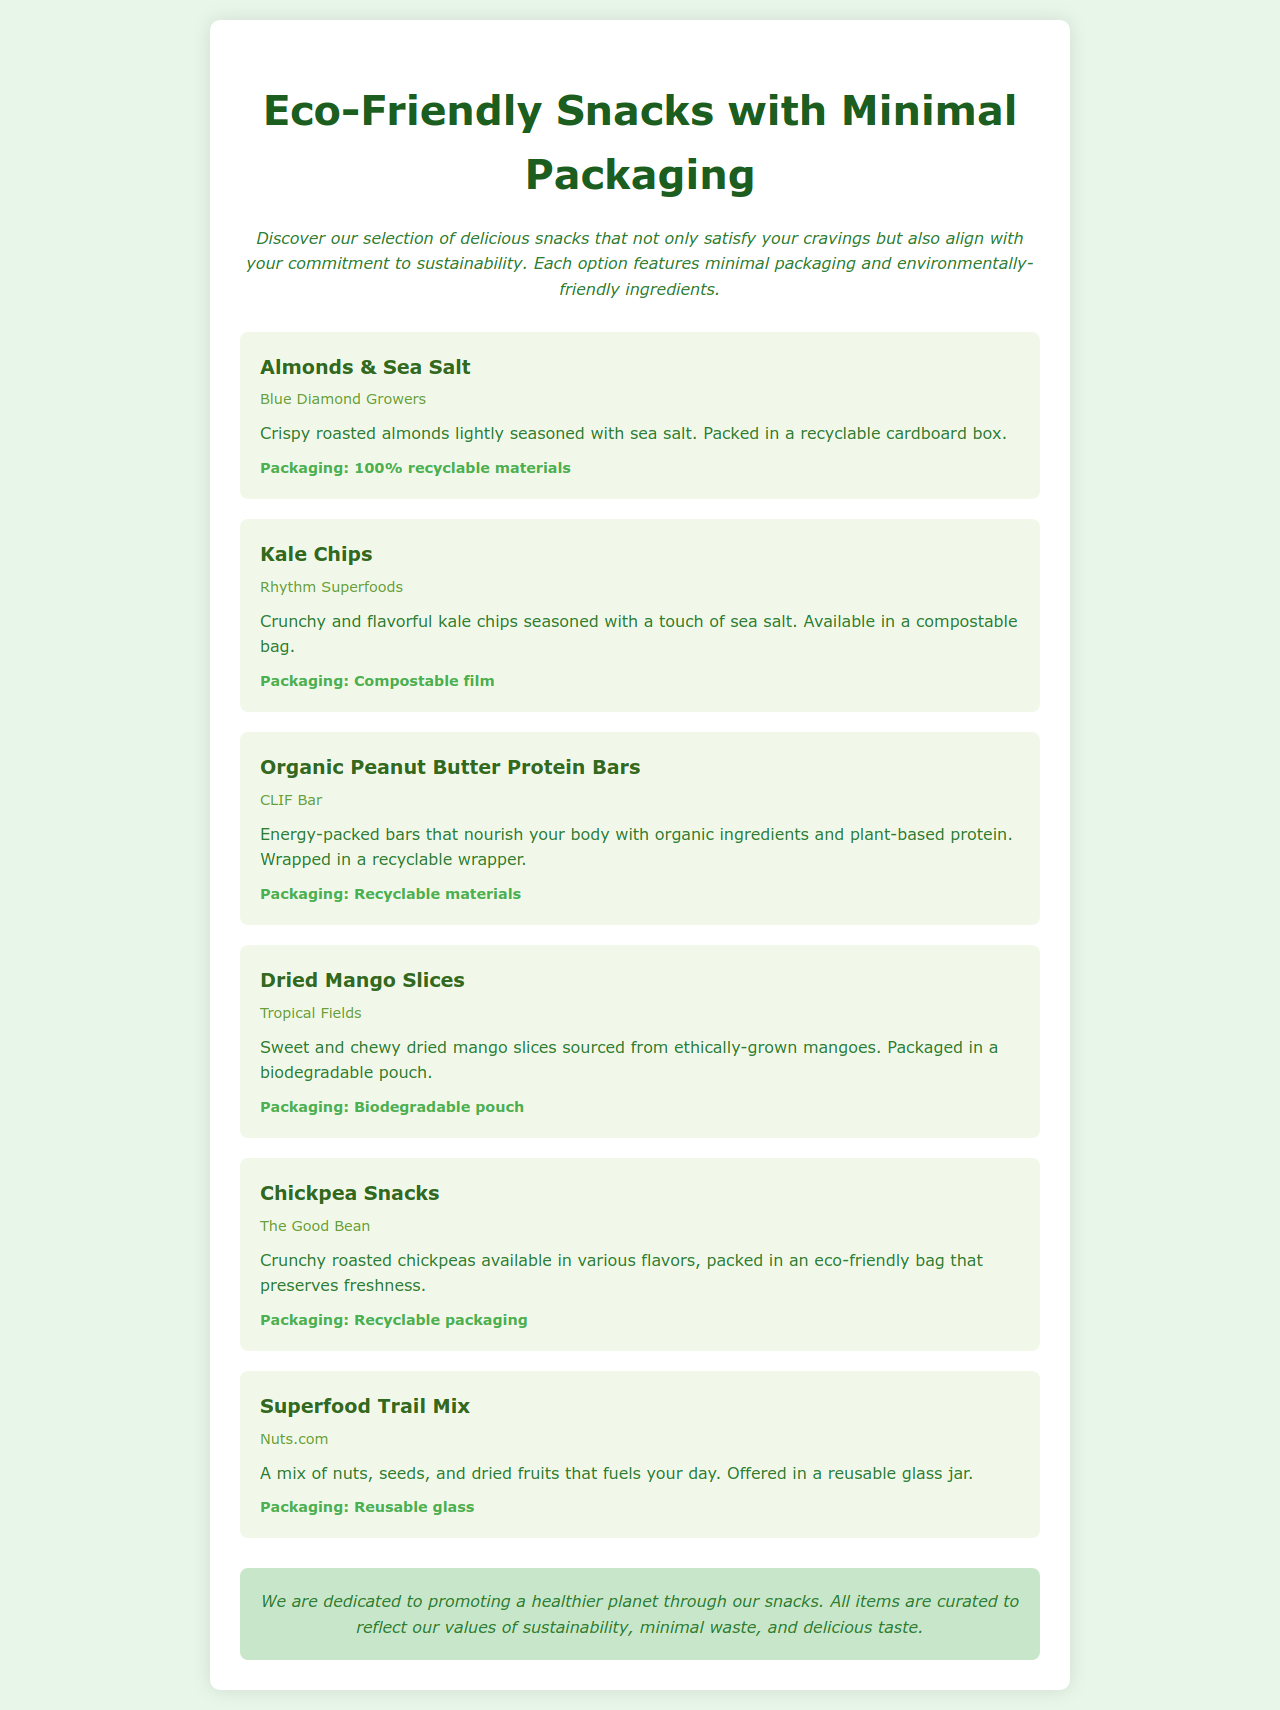What snack is packaged in a recyclable cardboard box? The document lists "Almonds & Sea Salt" as the snack that is packed in a recyclable cardboard box.
Answer: Almonds & Sea Salt What type of packaging do Kale Chips use? According to the description, Kale Chips are packaged in a compostable bag.
Answer: Compostable bag Which brand produces the Organic Peanut Butter Protein Bars? The document specifies that CLIF Bar is the brand that produces these protein bars.
Answer: CLIF Bar What is the packaging material for Dried Mango Slices? The document states that Dried Mango Slices are packaged in a biodegradable pouch.
Answer: Biodegradable pouch How are Superfood Trail Mix snacks packaged? The document reveals that Superfood Trail Mix is offered in a reusable glass jar.
Answer: Reusable glass jar Which snack features crunchy roasted chickpeas? The snack featuring crunchy roasted chickpeas is Chickpea Snacks by The Good Bean.
Answer: Chickpea Snacks What sustainability statement is mentioned in the document? The statement reflects the dedication to promoting a healthier planet and minimal waste through curated snacks.
Answer: A healthier planet through our snacks How many items are included in this eco-friendly snacks menu? The document lists a total of six unique snack items.
Answer: Six items 